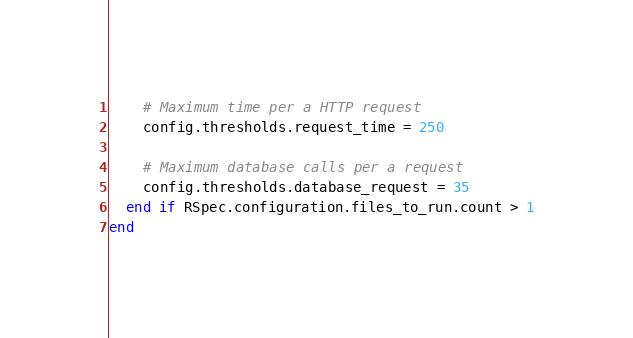Convert code to text. <code><loc_0><loc_0><loc_500><loc_500><_Ruby_>    # Maximum time per a HTTP request
    config.thresholds.request_time = 250

    # Maximum database calls per a request
    config.thresholds.database_request = 35
  end if RSpec.configuration.files_to_run.count > 1
end
</code> 